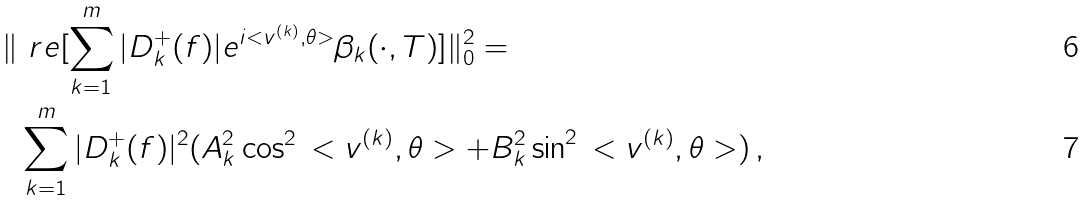<formula> <loc_0><loc_0><loc_500><loc_500>\| & \ r e [ \sum _ { k = 1 } ^ { m } | D ^ { + } _ { k } ( f ) | e ^ { i < v ^ { ( k ) } , \theta > } \beta _ { k } ( \cdot , T ) ] \| ^ { 2 } _ { 0 } = \\ & \sum _ { k = 1 } ^ { m } | D ^ { + } _ { k } ( f ) | ^ { 2 } ( A _ { k } ^ { 2 } \cos ^ { 2 } \, < v ^ { ( k ) } , \theta > + B _ { k } ^ { 2 } \sin ^ { 2 } \, < v ^ { ( k ) } , \theta > ) \, ,</formula> 